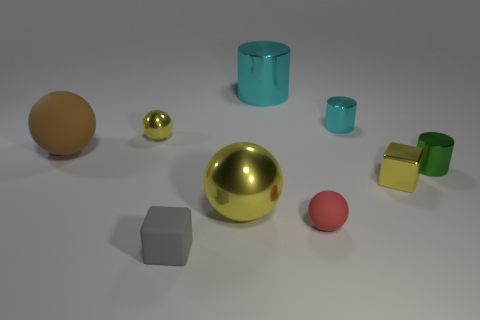Add 1 tiny things. How many objects exist? 10 Subtract all cylinders. How many objects are left? 6 Subtract all small cyan cylinders. Subtract all tiny brown cylinders. How many objects are left? 8 Add 1 big shiny spheres. How many big shiny spheres are left? 2 Add 6 small purple matte balls. How many small purple matte balls exist? 6 Subtract 0 purple balls. How many objects are left? 9 